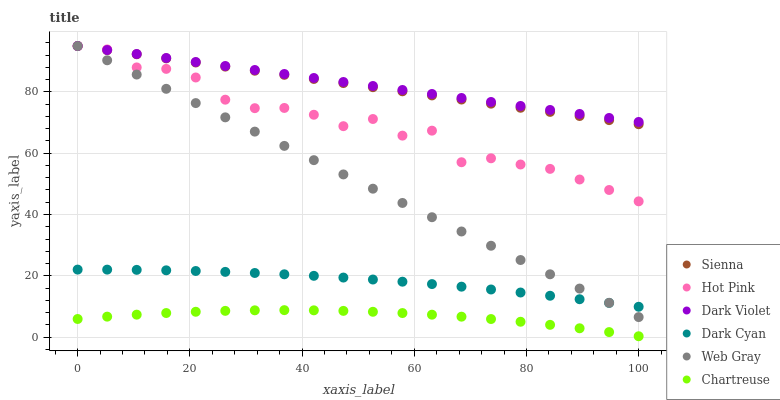Does Chartreuse have the minimum area under the curve?
Answer yes or no. Yes. Does Dark Violet have the maximum area under the curve?
Answer yes or no. Yes. Does Hot Pink have the minimum area under the curve?
Answer yes or no. No. Does Hot Pink have the maximum area under the curve?
Answer yes or no. No. Is Web Gray the smoothest?
Answer yes or no. Yes. Is Hot Pink the roughest?
Answer yes or no. Yes. Is Dark Violet the smoothest?
Answer yes or no. No. Is Dark Violet the roughest?
Answer yes or no. No. Does Chartreuse have the lowest value?
Answer yes or no. Yes. Does Hot Pink have the lowest value?
Answer yes or no. No. Does Sienna have the highest value?
Answer yes or no. Yes. Does Chartreuse have the highest value?
Answer yes or no. No. Is Dark Cyan less than Dark Violet?
Answer yes or no. Yes. Is Sienna greater than Dark Cyan?
Answer yes or no. Yes. Does Dark Violet intersect Web Gray?
Answer yes or no. Yes. Is Dark Violet less than Web Gray?
Answer yes or no. No. Is Dark Violet greater than Web Gray?
Answer yes or no. No. Does Dark Cyan intersect Dark Violet?
Answer yes or no. No. 